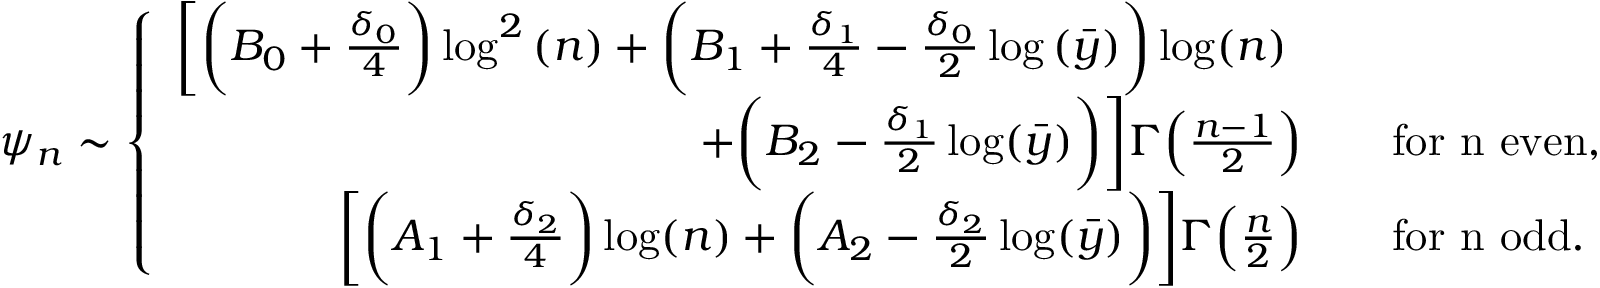Convert formula to latex. <formula><loc_0><loc_0><loc_500><loc_500>\psi _ { n } \sim \left \{ \begin{array} { r l } { \left [ \left ( B _ { 0 } + \frac { \delta _ { 0 } } { 4 } \right ) \log ^ { 2 } { ( n ) } + \left ( B _ { 1 } + \frac { \delta _ { 1 } } { 4 } - \frac { \delta _ { 0 } } { 2 } \log { ( \bar { y } ) } \right ) \log ( n ) \quad } \\ { + \left ( B _ { 2 } - \frac { \delta _ { 1 } } { 2 } \log ( \bar { y } ) \right ) \right ] \Gamma \left ( \frac { n - 1 } { 2 } \right ) \quad } & { f o r n e v e n , } \\ { \left [ \left ( A _ { 1 } + \frac { \delta _ { 2 } } { 4 } \right ) \log ( n ) + \left ( A _ { 2 } - \frac { \delta _ { 2 } } { 2 } \log ( \bar { y } ) \right ) \right ] \Gamma \left ( \frac { n } { 2 } \right ) \quad } & { f o r n o d d . } \end{array}</formula> 